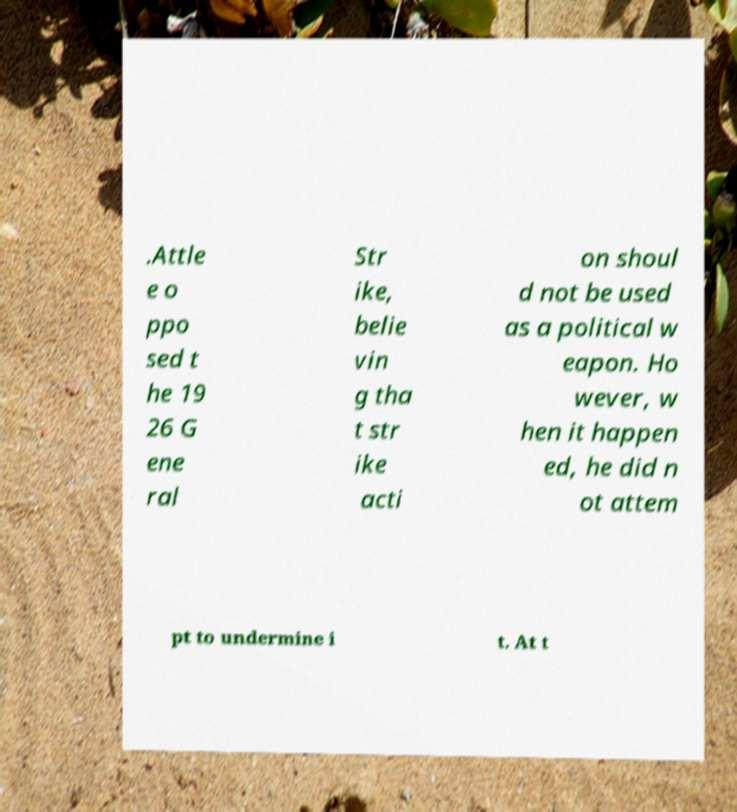Could you assist in decoding the text presented in this image and type it out clearly? .Attle e o ppo sed t he 19 26 G ene ral Str ike, belie vin g tha t str ike acti on shoul d not be used as a political w eapon. Ho wever, w hen it happen ed, he did n ot attem pt to undermine i t. At t 